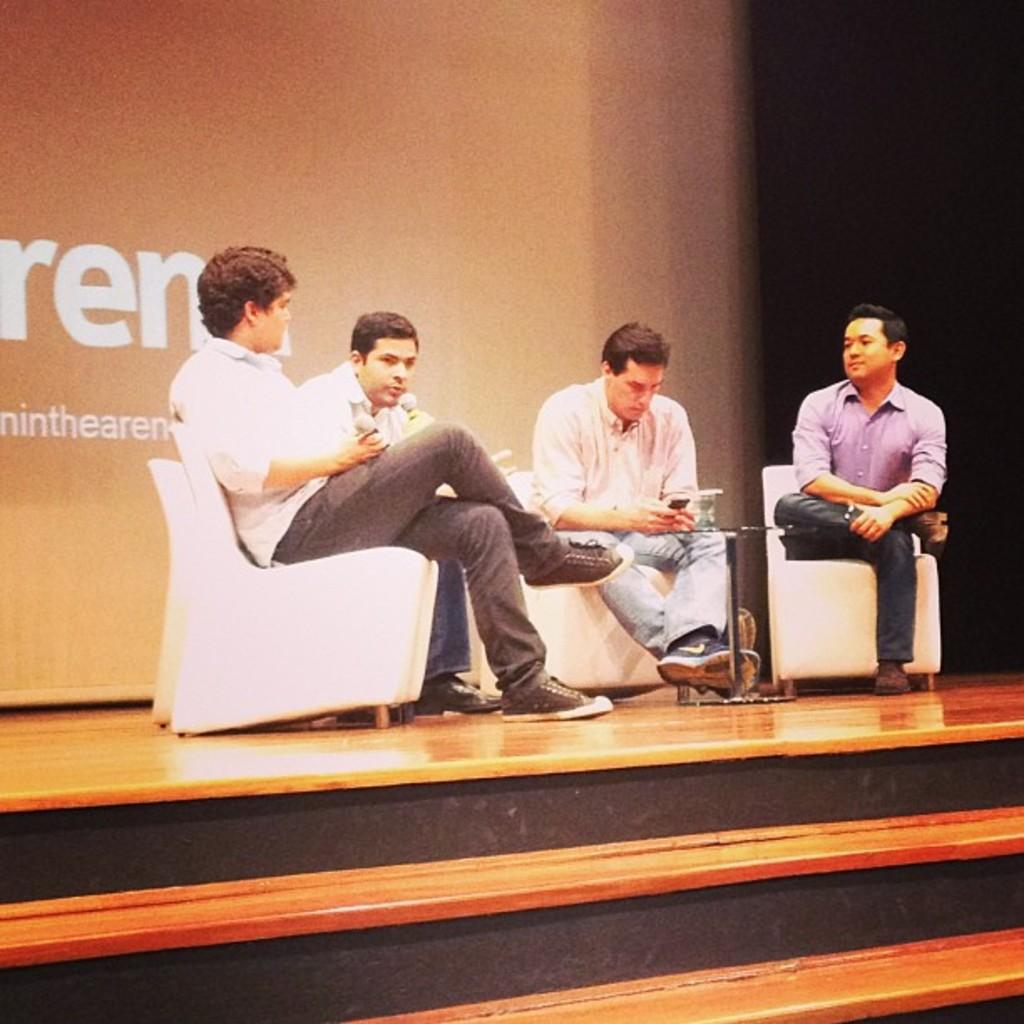How many people are in the image? There are four persons in the image. What are the persons doing in the image? The persons are sitting on chairs and holding microphones. What is the surface they are sitting on? There is a floor in the image. What can be seen in the background of the image? There is a banner in the background of the image. What type of game is being played in the image? There is no game being played in the image; the persons are holding microphones, which suggests they might be participating in a discussion or presentation. 